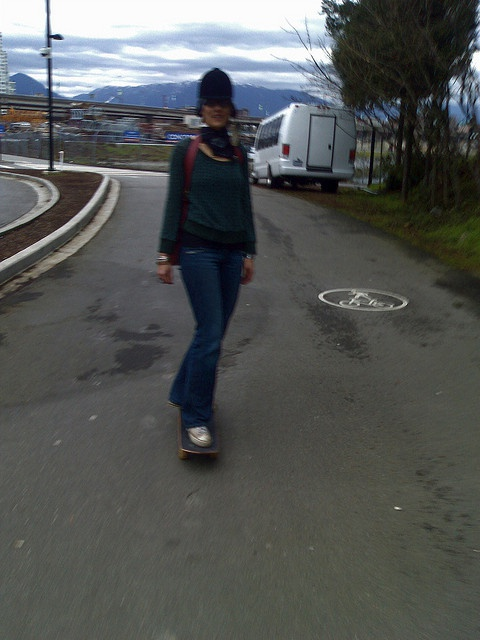Describe the objects in this image and their specific colors. I can see people in white, black, gray, maroon, and navy tones, bus in white, gray, darkgray, and black tones, backpack in white, black, maroon, purple, and brown tones, and skateboard in white, black, and gray tones in this image. 